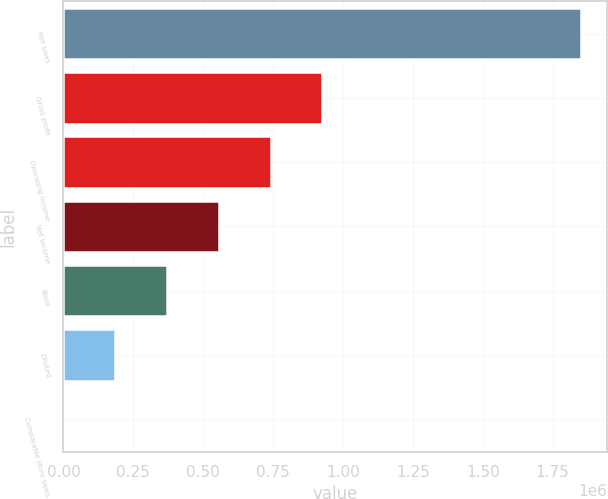Convert chart to OTSL. <chart><loc_0><loc_0><loc_500><loc_500><bar_chart><fcel>Net sales<fcel>Gross profit<fcel>Operating income<fcel>Net income<fcel>Basic<fcel>Diluted<fcel>Comparable store sales<nl><fcel>1.85253e+06<fcel>926267<fcel>741014<fcel>555761<fcel>370507<fcel>185254<fcel>0.5<nl></chart> 